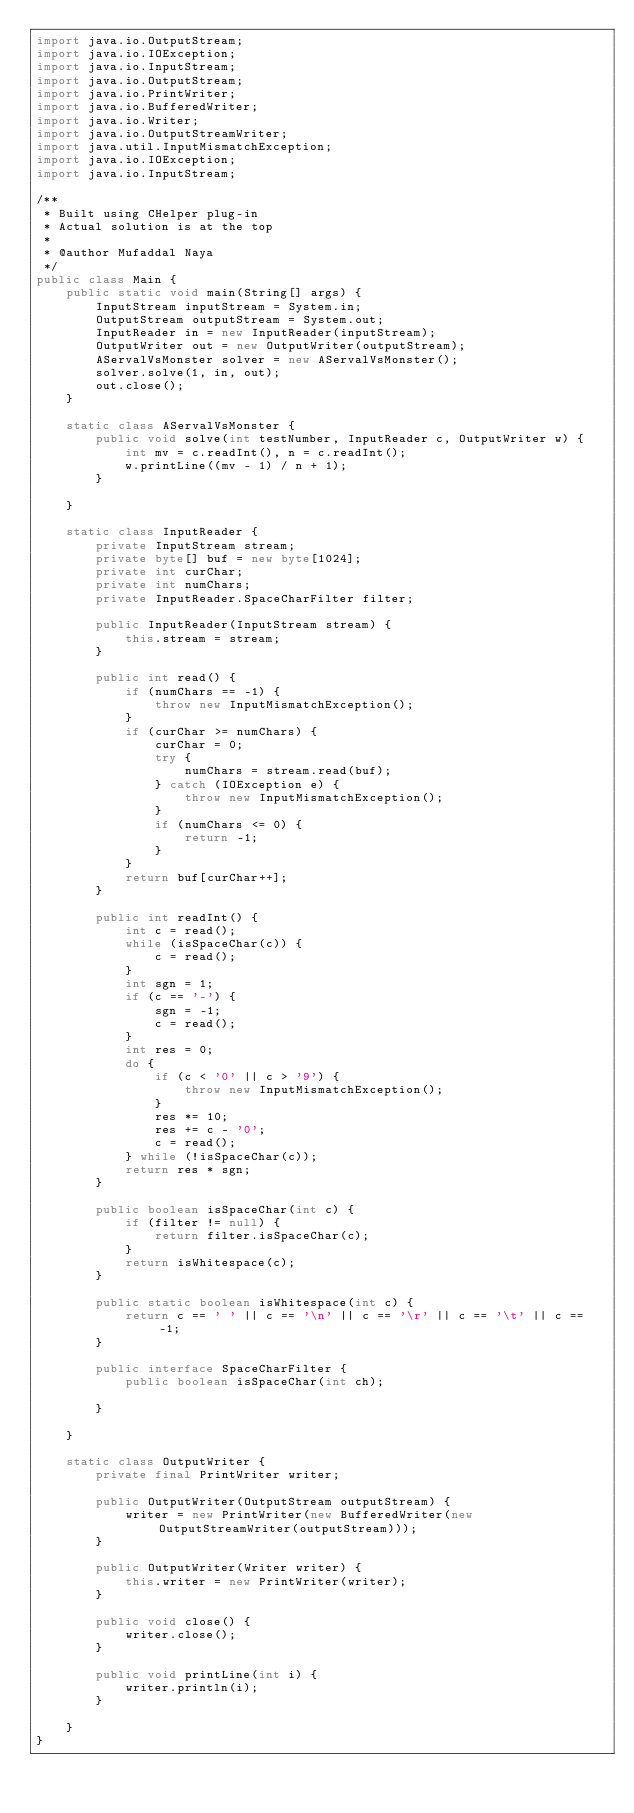<code> <loc_0><loc_0><loc_500><loc_500><_Java_>import java.io.OutputStream;
import java.io.IOException;
import java.io.InputStream;
import java.io.OutputStream;
import java.io.PrintWriter;
import java.io.BufferedWriter;
import java.io.Writer;
import java.io.OutputStreamWriter;
import java.util.InputMismatchException;
import java.io.IOException;
import java.io.InputStream;

/**
 * Built using CHelper plug-in
 * Actual solution is at the top
 *
 * @author Mufaddal Naya
 */
public class Main {
    public static void main(String[] args) {
        InputStream inputStream = System.in;
        OutputStream outputStream = System.out;
        InputReader in = new InputReader(inputStream);
        OutputWriter out = new OutputWriter(outputStream);
        AServalVsMonster solver = new AServalVsMonster();
        solver.solve(1, in, out);
        out.close();
    }

    static class AServalVsMonster {
        public void solve(int testNumber, InputReader c, OutputWriter w) {
            int mv = c.readInt(), n = c.readInt();
            w.printLine((mv - 1) / n + 1);
        }

    }

    static class InputReader {
        private InputStream stream;
        private byte[] buf = new byte[1024];
        private int curChar;
        private int numChars;
        private InputReader.SpaceCharFilter filter;

        public InputReader(InputStream stream) {
            this.stream = stream;
        }

        public int read() {
            if (numChars == -1) {
                throw new InputMismatchException();
            }
            if (curChar >= numChars) {
                curChar = 0;
                try {
                    numChars = stream.read(buf);
                } catch (IOException e) {
                    throw new InputMismatchException();
                }
                if (numChars <= 0) {
                    return -1;
                }
            }
            return buf[curChar++];
        }

        public int readInt() {
            int c = read();
            while (isSpaceChar(c)) {
                c = read();
            }
            int sgn = 1;
            if (c == '-') {
                sgn = -1;
                c = read();
            }
            int res = 0;
            do {
                if (c < '0' || c > '9') {
                    throw new InputMismatchException();
                }
                res *= 10;
                res += c - '0';
                c = read();
            } while (!isSpaceChar(c));
            return res * sgn;
        }

        public boolean isSpaceChar(int c) {
            if (filter != null) {
                return filter.isSpaceChar(c);
            }
            return isWhitespace(c);
        }

        public static boolean isWhitespace(int c) {
            return c == ' ' || c == '\n' || c == '\r' || c == '\t' || c == -1;
        }

        public interface SpaceCharFilter {
            public boolean isSpaceChar(int ch);

        }

    }

    static class OutputWriter {
        private final PrintWriter writer;

        public OutputWriter(OutputStream outputStream) {
            writer = new PrintWriter(new BufferedWriter(new OutputStreamWriter(outputStream)));
        }

        public OutputWriter(Writer writer) {
            this.writer = new PrintWriter(writer);
        }

        public void close() {
            writer.close();
        }

        public void printLine(int i) {
            writer.println(i);
        }

    }
}

</code> 